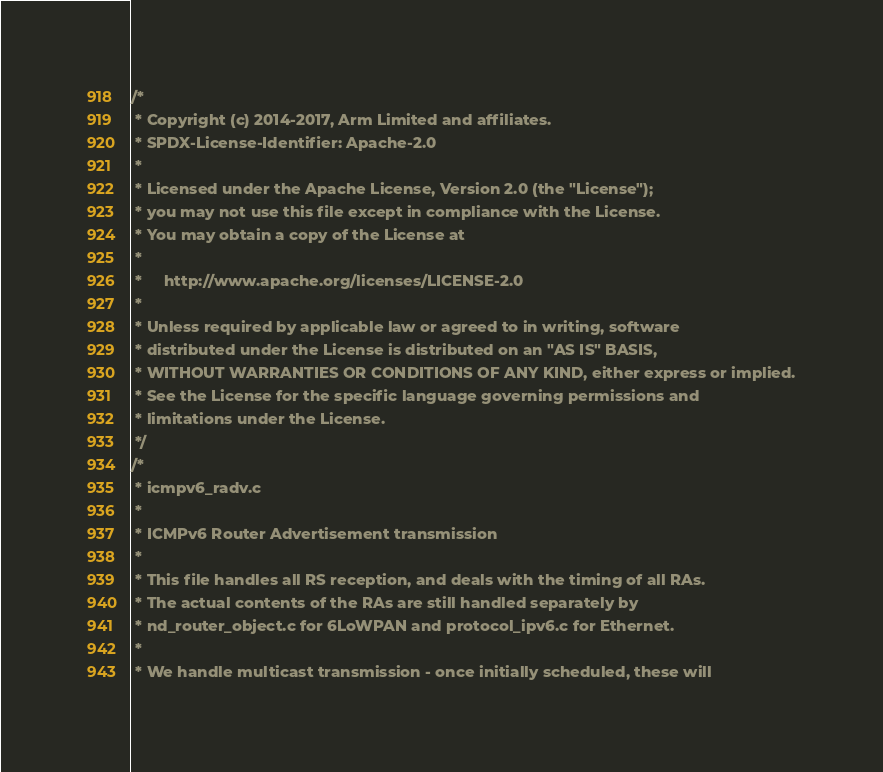<code> <loc_0><loc_0><loc_500><loc_500><_C_>/*
 * Copyright (c) 2014-2017, Arm Limited and affiliates.
 * SPDX-License-Identifier: Apache-2.0
 *
 * Licensed under the Apache License, Version 2.0 (the "License");
 * you may not use this file except in compliance with the License.
 * You may obtain a copy of the License at
 *
 *     http://www.apache.org/licenses/LICENSE-2.0
 *
 * Unless required by applicable law or agreed to in writing, software
 * distributed under the License is distributed on an "AS IS" BASIS,
 * WITHOUT WARRANTIES OR CONDITIONS OF ANY KIND, either express or implied.
 * See the License for the specific language governing permissions and
 * limitations under the License.
 */
/*
 * icmpv6_radv.c
 *
 * ICMPv6 Router Advertisement transmission
 *
 * This file handles all RS reception, and deals with the timing of all RAs.
 * The actual contents of the RAs are still handled separately by
 * nd_router_object.c for 6LoWPAN and protocol_ipv6.c for Ethernet.
 *
 * We handle multicast transmission - once initially scheduled, these will</code> 